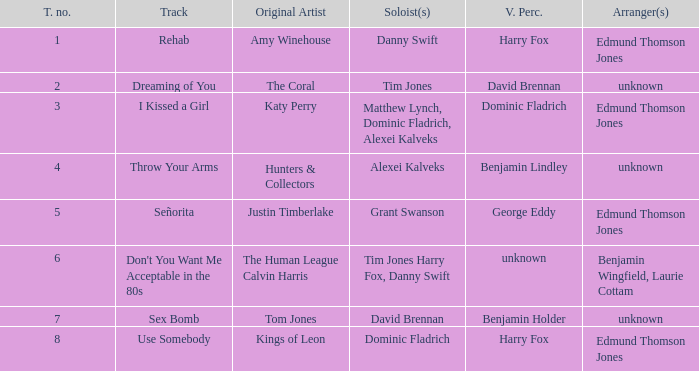Who is the artist where the vocal percussionist is Benjamin Holder? Tom Jones. Help me parse the entirety of this table. {'header': ['T. no.', 'Track', 'Original Artist', 'Soloist(s)', 'V. Perc.', 'Arranger(s)'], 'rows': [['1', 'Rehab', 'Amy Winehouse', 'Danny Swift', 'Harry Fox', 'Edmund Thomson Jones'], ['2', 'Dreaming of You', 'The Coral', 'Tim Jones', 'David Brennan', 'unknown'], ['3', 'I Kissed a Girl', 'Katy Perry', 'Matthew Lynch, Dominic Fladrich, Alexei Kalveks', 'Dominic Fladrich', 'Edmund Thomson Jones'], ['4', 'Throw Your Arms', 'Hunters & Collectors', 'Alexei Kalveks', 'Benjamin Lindley', 'unknown'], ['5', 'Señorita', 'Justin Timberlake', 'Grant Swanson', 'George Eddy', 'Edmund Thomson Jones'], ['6', "Don't You Want Me Acceptable in the 80s", 'The Human League Calvin Harris', 'Tim Jones Harry Fox, Danny Swift', 'unknown', 'Benjamin Wingfield, Laurie Cottam'], ['7', 'Sex Bomb', 'Tom Jones', 'David Brennan', 'Benjamin Holder', 'unknown'], ['8', 'Use Somebody', 'Kings of Leon', 'Dominic Fladrich', 'Harry Fox', 'Edmund Thomson Jones']]} 